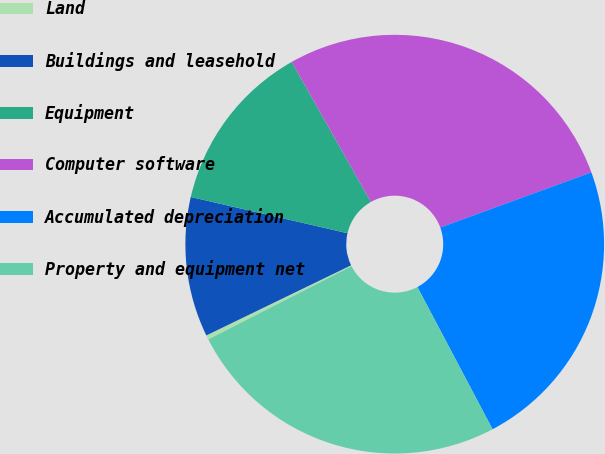<chart> <loc_0><loc_0><loc_500><loc_500><pie_chart><fcel>Land<fcel>Buildings and leasehold<fcel>Equipment<fcel>Computer software<fcel>Accumulated depreciation<fcel>Property and equipment net<nl><fcel>0.34%<fcel>10.8%<fcel>13.19%<fcel>27.62%<fcel>22.83%<fcel>25.22%<nl></chart> 